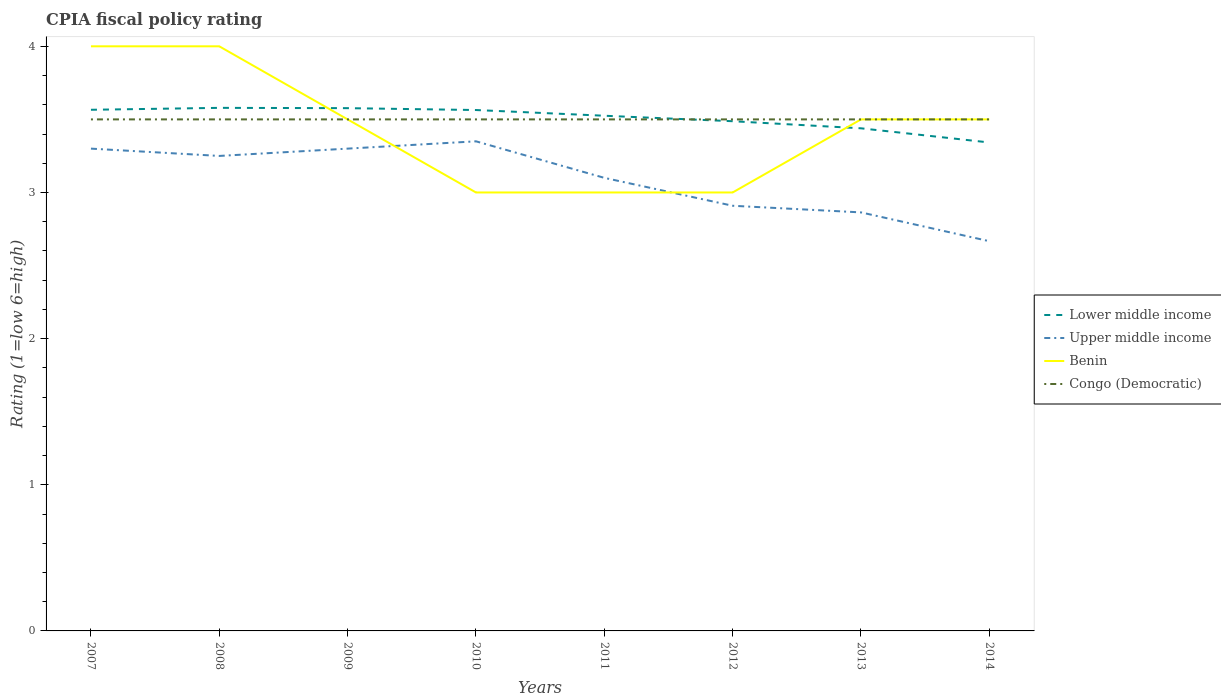How many different coloured lines are there?
Give a very brief answer. 4. Does the line corresponding to Lower middle income intersect with the line corresponding to Benin?
Offer a terse response. Yes. Across all years, what is the maximum CPIA rating in Benin?
Provide a short and direct response. 3. In which year was the CPIA rating in Lower middle income maximum?
Offer a very short reply. 2014. What is the total CPIA rating in Upper middle income in the graph?
Provide a succinct answer. 0. How many years are there in the graph?
Make the answer very short. 8. What is the difference between two consecutive major ticks on the Y-axis?
Make the answer very short. 1. Are the values on the major ticks of Y-axis written in scientific E-notation?
Keep it short and to the point. No. Does the graph contain any zero values?
Your answer should be very brief. No. Does the graph contain grids?
Offer a very short reply. No. Where does the legend appear in the graph?
Give a very brief answer. Center right. How many legend labels are there?
Give a very brief answer. 4. How are the legend labels stacked?
Your answer should be compact. Vertical. What is the title of the graph?
Make the answer very short. CPIA fiscal policy rating. Does "Zimbabwe" appear as one of the legend labels in the graph?
Provide a short and direct response. No. What is the label or title of the X-axis?
Make the answer very short. Years. What is the label or title of the Y-axis?
Keep it short and to the point. Rating (1=low 6=high). What is the Rating (1=low 6=high) in Lower middle income in 2007?
Your answer should be very brief. 3.57. What is the Rating (1=low 6=high) of Upper middle income in 2007?
Make the answer very short. 3.3. What is the Rating (1=low 6=high) in Benin in 2007?
Ensure brevity in your answer.  4. What is the Rating (1=low 6=high) of Congo (Democratic) in 2007?
Give a very brief answer. 3.5. What is the Rating (1=low 6=high) of Lower middle income in 2008?
Provide a succinct answer. 3.58. What is the Rating (1=low 6=high) of Upper middle income in 2008?
Your answer should be very brief. 3.25. What is the Rating (1=low 6=high) of Benin in 2008?
Keep it short and to the point. 4. What is the Rating (1=low 6=high) in Lower middle income in 2009?
Keep it short and to the point. 3.58. What is the Rating (1=low 6=high) in Upper middle income in 2009?
Make the answer very short. 3.3. What is the Rating (1=low 6=high) in Benin in 2009?
Offer a very short reply. 3.5. What is the Rating (1=low 6=high) in Lower middle income in 2010?
Your answer should be compact. 3.56. What is the Rating (1=low 6=high) in Upper middle income in 2010?
Offer a very short reply. 3.35. What is the Rating (1=low 6=high) of Lower middle income in 2011?
Ensure brevity in your answer.  3.52. What is the Rating (1=low 6=high) of Benin in 2011?
Make the answer very short. 3. What is the Rating (1=low 6=high) in Congo (Democratic) in 2011?
Keep it short and to the point. 3.5. What is the Rating (1=low 6=high) in Lower middle income in 2012?
Your response must be concise. 3.49. What is the Rating (1=low 6=high) in Upper middle income in 2012?
Offer a very short reply. 2.91. What is the Rating (1=low 6=high) in Benin in 2012?
Your response must be concise. 3. What is the Rating (1=low 6=high) of Congo (Democratic) in 2012?
Make the answer very short. 3.5. What is the Rating (1=low 6=high) in Lower middle income in 2013?
Ensure brevity in your answer.  3.44. What is the Rating (1=low 6=high) of Upper middle income in 2013?
Keep it short and to the point. 2.86. What is the Rating (1=low 6=high) of Benin in 2013?
Provide a short and direct response. 3.5. What is the Rating (1=low 6=high) in Congo (Democratic) in 2013?
Offer a terse response. 3.5. What is the Rating (1=low 6=high) of Lower middle income in 2014?
Offer a terse response. 3.34. What is the Rating (1=low 6=high) of Upper middle income in 2014?
Provide a succinct answer. 2.67. Across all years, what is the maximum Rating (1=low 6=high) in Lower middle income?
Provide a succinct answer. 3.58. Across all years, what is the maximum Rating (1=low 6=high) of Upper middle income?
Keep it short and to the point. 3.35. Across all years, what is the minimum Rating (1=low 6=high) of Lower middle income?
Provide a succinct answer. 3.34. Across all years, what is the minimum Rating (1=low 6=high) in Upper middle income?
Your response must be concise. 2.67. Across all years, what is the minimum Rating (1=low 6=high) in Congo (Democratic)?
Provide a short and direct response. 3.5. What is the total Rating (1=low 6=high) of Lower middle income in the graph?
Make the answer very short. 28.08. What is the total Rating (1=low 6=high) of Upper middle income in the graph?
Ensure brevity in your answer.  24.74. What is the total Rating (1=low 6=high) of Congo (Democratic) in the graph?
Provide a succinct answer. 28. What is the difference between the Rating (1=low 6=high) in Lower middle income in 2007 and that in 2008?
Ensure brevity in your answer.  -0.01. What is the difference between the Rating (1=low 6=high) of Lower middle income in 2007 and that in 2009?
Give a very brief answer. -0.01. What is the difference between the Rating (1=low 6=high) in Upper middle income in 2007 and that in 2009?
Offer a very short reply. 0. What is the difference between the Rating (1=low 6=high) in Benin in 2007 and that in 2009?
Your response must be concise. 0.5. What is the difference between the Rating (1=low 6=high) in Congo (Democratic) in 2007 and that in 2009?
Provide a short and direct response. 0. What is the difference between the Rating (1=low 6=high) in Lower middle income in 2007 and that in 2010?
Give a very brief answer. 0. What is the difference between the Rating (1=low 6=high) in Benin in 2007 and that in 2010?
Your response must be concise. 1. What is the difference between the Rating (1=low 6=high) in Congo (Democratic) in 2007 and that in 2010?
Your answer should be very brief. 0. What is the difference between the Rating (1=low 6=high) in Lower middle income in 2007 and that in 2011?
Your answer should be compact. 0.04. What is the difference between the Rating (1=low 6=high) of Upper middle income in 2007 and that in 2011?
Ensure brevity in your answer.  0.2. What is the difference between the Rating (1=low 6=high) in Benin in 2007 and that in 2011?
Your response must be concise. 1. What is the difference between the Rating (1=low 6=high) of Congo (Democratic) in 2007 and that in 2011?
Offer a terse response. 0. What is the difference between the Rating (1=low 6=high) of Lower middle income in 2007 and that in 2012?
Make the answer very short. 0.08. What is the difference between the Rating (1=low 6=high) in Upper middle income in 2007 and that in 2012?
Offer a terse response. 0.39. What is the difference between the Rating (1=low 6=high) in Lower middle income in 2007 and that in 2013?
Your answer should be very brief. 0.13. What is the difference between the Rating (1=low 6=high) in Upper middle income in 2007 and that in 2013?
Ensure brevity in your answer.  0.44. What is the difference between the Rating (1=low 6=high) of Benin in 2007 and that in 2013?
Make the answer very short. 0.5. What is the difference between the Rating (1=low 6=high) of Congo (Democratic) in 2007 and that in 2013?
Keep it short and to the point. 0. What is the difference between the Rating (1=low 6=high) in Lower middle income in 2007 and that in 2014?
Your response must be concise. 0.22. What is the difference between the Rating (1=low 6=high) in Upper middle income in 2007 and that in 2014?
Offer a terse response. 0.63. What is the difference between the Rating (1=low 6=high) of Lower middle income in 2008 and that in 2009?
Make the answer very short. 0. What is the difference between the Rating (1=low 6=high) in Congo (Democratic) in 2008 and that in 2009?
Ensure brevity in your answer.  0. What is the difference between the Rating (1=low 6=high) in Lower middle income in 2008 and that in 2010?
Your response must be concise. 0.01. What is the difference between the Rating (1=low 6=high) of Congo (Democratic) in 2008 and that in 2010?
Make the answer very short. 0. What is the difference between the Rating (1=low 6=high) in Lower middle income in 2008 and that in 2011?
Make the answer very short. 0.05. What is the difference between the Rating (1=low 6=high) of Lower middle income in 2008 and that in 2012?
Your answer should be compact. 0.09. What is the difference between the Rating (1=low 6=high) of Upper middle income in 2008 and that in 2012?
Your answer should be compact. 0.34. What is the difference between the Rating (1=low 6=high) of Benin in 2008 and that in 2012?
Make the answer very short. 1. What is the difference between the Rating (1=low 6=high) in Congo (Democratic) in 2008 and that in 2012?
Provide a short and direct response. 0. What is the difference between the Rating (1=low 6=high) of Lower middle income in 2008 and that in 2013?
Provide a short and direct response. 0.14. What is the difference between the Rating (1=low 6=high) in Upper middle income in 2008 and that in 2013?
Offer a terse response. 0.39. What is the difference between the Rating (1=low 6=high) of Benin in 2008 and that in 2013?
Provide a succinct answer. 0.5. What is the difference between the Rating (1=low 6=high) in Lower middle income in 2008 and that in 2014?
Make the answer very short. 0.24. What is the difference between the Rating (1=low 6=high) in Upper middle income in 2008 and that in 2014?
Your answer should be very brief. 0.58. What is the difference between the Rating (1=low 6=high) in Benin in 2008 and that in 2014?
Keep it short and to the point. 0.5. What is the difference between the Rating (1=low 6=high) of Lower middle income in 2009 and that in 2010?
Provide a short and direct response. 0.01. What is the difference between the Rating (1=low 6=high) of Upper middle income in 2009 and that in 2010?
Offer a very short reply. -0.05. What is the difference between the Rating (1=low 6=high) of Benin in 2009 and that in 2010?
Keep it short and to the point. 0.5. What is the difference between the Rating (1=low 6=high) in Lower middle income in 2009 and that in 2011?
Offer a very short reply. 0.05. What is the difference between the Rating (1=low 6=high) in Upper middle income in 2009 and that in 2011?
Your answer should be compact. 0.2. What is the difference between the Rating (1=low 6=high) in Congo (Democratic) in 2009 and that in 2011?
Keep it short and to the point. 0. What is the difference between the Rating (1=low 6=high) of Lower middle income in 2009 and that in 2012?
Your answer should be compact. 0.09. What is the difference between the Rating (1=low 6=high) in Upper middle income in 2009 and that in 2012?
Keep it short and to the point. 0.39. What is the difference between the Rating (1=low 6=high) in Benin in 2009 and that in 2012?
Your answer should be compact. 0.5. What is the difference between the Rating (1=low 6=high) in Lower middle income in 2009 and that in 2013?
Ensure brevity in your answer.  0.14. What is the difference between the Rating (1=low 6=high) in Upper middle income in 2009 and that in 2013?
Your response must be concise. 0.44. What is the difference between the Rating (1=low 6=high) of Benin in 2009 and that in 2013?
Offer a very short reply. 0. What is the difference between the Rating (1=low 6=high) of Congo (Democratic) in 2009 and that in 2013?
Offer a very short reply. 0. What is the difference between the Rating (1=low 6=high) in Lower middle income in 2009 and that in 2014?
Give a very brief answer. 0.23. What is the difference between the Rating (1=low 6=high) of Upper middle income in 2009 and that in 2014?
Keep it short and to the point. 0.63. What is the difference between the Rating (1=low 6=high) of Benin in 2009 and that in 2014?
Ensure brevity in your answer.  0. What is the difference between the Rating (1=low 6=high) of Lower middle income in 2010 and that in 2011?
Provide a short and direct response. 0.04. What is the difference between the Rating (1=low 6=high) in Upper middle income in 2010 and that in 2011?
Offer a very short reply. 0.25. What is the difference between the Rating (1=low 6=high) in Benin in 2010 and that in 2011?
Offer a terse response. 0. What is the difference between the Rating (1=low 6=high) of Congo (Democratic) in 2010 and that in 2011?
Your response must be concise. 0. What is the difference between the Rating (1=low 6=high) of Lower middle income in 2010 and that in 2012?
Your response must be concise. 0.08. What is the difference between the Rating (1=low 6=high) of Upper middle income in 2010 and that in 2012?
Your response must be concise. 0.44. What is the difference between the Rating (1=low 6=high) of Lower middle income in 2010 and that in 2013?
Provide a succinct answer. 0.13. What is the difference between the Rating (1=low 6=high) of Upper middle income in 2010 and that in 2013?
Offer a terse response. 0.49. What is the difference between the Rating (1=low 6=high) in Benin in 2010 and that in 2013?
Your response must be concise. -0.5. What is the difference between the Rating (1=low 6=high) of Lower middle income in 2010 and that in 2014?
Give a very brief answer. 0.22. What is the difference between the Rating (1=low 6=high) of Upper middle income in 2010 and that in 2014?
Your answer should be very brief. 0.68. What is the difference between the Rating (1=low 6=high) of Benin in 2010 and that in 2014?
Make the answer very short. -0.5. What is the difference between the Rating (1=low 6=high) of Congo (Democratic) in 2010 and that in 2014?
Offer a very short reply. 0. What is the difference between the Rating (1=low 6=high) in Lower middle income in 2011 and that in 2012?
Your response must be concise. 0.04. What is the difference between the Rating (1=low 6=high) of Upper middle income in 2011 and that in 2012?
Provide a succinct answer. 0.19. What is the difference between the Rating (1=low 6=high) of Congo (Democratic) in 2011 and that in 2012?
Give a very brief answer. 0. What is the difference between the Rating (1=low 6=high) of Lower middle income in 2011 and that in 2013?
Offer a terse response. 0.09. What is the difference between the Rating (1=low 6=high) in Upper middle income in 2011 and that in 2013?
Give a very brief answer. 0.24. What is the difference between the Rating (1=low 6=high) in Lower middle income in 2011 and that in 2014?
Offer a very short reply. 0.18. What is the difference between the Rating (1=low 6=high) in Upper middle income in 2011 and that in 2014?
Your answer should be very brief. 0.43. What is the difference between the Rating (1=low 6=high) of Congo (Democratic) in 2011 and that in 2014?
Ensure brevity in your answer.  0. What is the difference between the Rating (1=low 6=high) in Lower middle income in 2012 and that in 2013?
Keep it short and to the point. 0.05. What is the difference between the Rating (1=low 6=high) of Upper middle income in 2012 and that in 2013?
Your answer should be very brief. 0.05. What is the difference between the Rating (1=low 6=high) in Lower middle income in 2012 and that in 2014?
Your response must be concise. 0.15. What is the difference between the Rating (1=low 6=high) in Upper middle income in 2012 and that in 2014?
Provide a short and direct response. 0.24. What is the difference between the Rating (1=low 6=high) of Lower middle income in 2013 and that in 2014?
Your answer should be compact. 0.1. What is the difference between the Rating (1=low 6=high) in Upper middle income in 2013 and that in 2014?
Make the answer very short. 0.2. What is the difference between the Rating (1=low 6=high) in Benin in 2013 and that in 2014?
Make the answer very short. 0. What is the difference between the Rating (1=low 6=high) in Lower middle income in 2007 and the Rating (1=low 6=high) in Upper middle income in 2008?
Your response must be concise. 0.32. What is the difference between the Rating (1=low 6=high) in Lower middle income in 2007 and the Rating (1=low 6=high) in Benin in 2008?
Your answer should be compact. -0.43. What is the difference between the Rating (1=low 6=high) in Lower middle income in 2007 and the Rating (1=low 6=high) in Congo (Democratic) in 2008?
Offer a terse response. 0.07. What is the difference between the Rating (1=low 6=high) in Lower middle income in 2007 and the Rating (1=low 6=high) in Upper middle income in 2009?
Your answer should be compact. 0.27. What is the difference between the Rating (1=low 6=high) in Lower middle income in 2007 and the Rating (1=low 6=high) in Benin in 2009?
Your response must be concise. 0.07. What is the difference between the Rating (1=low 6=high) in Lower middle income in 2007 and the Rating (1=low 6=high) in Congo (Democratic) in 2009?
Offer a very short reply. 0.07. What is the difference between the Rating (1=low 6=high) in Upper middle income in 2007 and the Rating (1=low 6=high) in Congo (Democratic) in 2009?
Your answer should be compact. -0.2. What is the difference between the Rating (1=low 6=high) in Lower middle income in 2007 and the Rating (1=low 6=high) in Upper middle income in 2010?
Give a very brief answer. 0.22. What is the difference between the Rating (1=low 6=high) of Lower middle income in 2007 and the Rating (1=low 6=high) of Benin in 2010?
Your answer should be compact. 0.57. What is the difference between the Rating (1=low 6=high) of Lower middle income in 2007 and the Rating (1=low 6=high) of Congo (Democratic) in 2010?
Offer a terse response. 0.07. What is the difference between the Rating (1=low 6=high) of Upper middle income in 2007 and the Rating (1=low 6=high) of Benin in 2010?
Provide a short and direct response. 0.3. What is the difference between the Rating (1=low 6=high) in Benin in 2007 and the Rating (1=low 6=high) in Congo (Democratic) in 2010?
Keep it short and to the point. 0.5. What is the difference between the Rating (1=low 6=high) of Lower middle income in 2007 and the Rating (1=low 6=high) of Upper middle income in 2011?
Provide a succinct answer. 0.47. What is the difference between the Rating (1=low 6=high) in Lower middle income in 2007 and the Rating (1=low 6=high) in Benin in 2011?
Provide a succinct answer. 0.57. What is the difference between the Rating (1=low 6=high) of Lower middle income in 2007 and the Rating (1=low 6=high) of Congo (Democratic) in 2011?
Your response must be concise. 0.07. What is the difference between the Rating (1=low 6=high) in Upper middle income in 2007 and the Rating (1=low 6=high) in Congo (Democratic) in 2011?
Provide a succinct answer. -0.2. What is the difference between the Rating (1=low 6=high) in Lower middle income in 2007 and the Rating (1=low 6=high) in Upper middle income in 2012?
Offer a very short reply. 0.66. What is the difference between the Rating (1=low 6=high) of Lower middle income in 2007 and the Rating (1=low 6=high) of Benin in 2012?
Your response must be concise. 0.57. What is the difference between the Rating (1=low 6=high) of Lower middle income in 2007 and the Rating (1=low 6=high) of Congo (Democratic) in 2012?
Offer a very short reply. 0.07. What is the difference between the Rating (1=low 6=high) in Upper middle income in 2007 and the Rating (1=low 6=high) in Benin in 2012?
Make the answer very short. 0.3. What is the difference between the Rating (1=low 6=high) in Upper middle income in 2007 and the Rating (1=low 6=high) in Congo (Democratic) in 2012?
Your response must be concise. -0.2. What is the difference between the Rating (1=low 6=high) of Lower middle income in 2007 and the Rating (1=low 6=high) of Upper middle income in 2013?
Ensure brevity in your answer.  0.7. What is the difference between the Rating (1=low 6=high) of Lower middle income in 2007 and the Rating (1=low 6=high) of Benin in 2013?
Give a very brief answer. 0.07. What is the difference between the Rating (1=low 6=high) of Lower middle income in 2007 and the Rating (1=low 6=high) of Congo (Democratic) in 2013?
Keep it short and to the point. 0.07. What is the difference between the Rating (1=low 6=high) of Upper middle income in 2007 and the Rating (1=low 6=high) of Congo (Democratic) in 2013?
Offer a very short reply. -0.2. What is the difference between the Rating (1=low 6=high) of Benin in 2007 and the Rating (1=low 6=high) of Congo (Democratic) in 2013?
Give a very brief answer. 0.5. What is the difference between the Rating (1=low 6=high) of Lower middle income in 2007 and the Rating (1=low 6=high) of Upper middle income in 2014?
Provide a succinct answer. 0.9. What is the difference between the Rating (1=low 6=high) in Lower middle income in 2007 and the Rating (1=low 6=high) in Benin in 2014?
Your answer should be compact. 0.07. What is the difference between the Rating (1=low 6=high) of Lower middle income in 2007 and the Rating (1=low 6=high) of Congo (Democratic) in 2014?
Provide a short and direct response. 0.07. What is the difference between the Rating (1=low 6=high) of Benin in 2007 and the Rating (1=low 6=high) of Congo (Democratic) in 2014?
Ensure brevity in your answer.  0.5. What is the difference between the Rating (1=low 6=high) of Lower middle income in 2008 and the Rating (1=low 6=high) of Upper middle income in 2009?
Provide a succinct answer. 0.28. What is the difference between the Rating (1=low 6=high) in Lower middle income in 2008 and the Rating (1=low 6=high) in Benin in 2009?
Provide a short and direct response. 0.08. What is the difference between the Rating (1=low 6=high) in Lower middle income in 2008 and the Rating (1=low 6=high) in Congo (Democratic) in 2009?
Offer a terse response. 0.08. What is the difference between the Rating (1=low 6=high) of Upper middle income in 2008 and the Rating (1=low 6=high) of Benin in 2009?
Your response must be concise. -0.25. What is the difference between the Rating (1=low 6=high) of Upper middle income in 2008 and the Rating (1=low 6=high) of Congo (Democratic) in 2009?
Your answer should be compact. -0.25. What is the difference between the Rating (1=low 6=high) in Benin in 2008 and the Rating (1=low 6=high) in Congo (Democratic) in 2009?
Ensure brevity in your answer.  0.5. What is the difference between the Rating (1=low 6=high) in Lower middle income in 2008 and the Rating (1=low 6=high) in Upper middle income in 2010?
Offer a terse response. 0.23. What is the difference between the Rating (1=low 6=high) of Lower middle income in 2008 and the Rating (1=low 6=high) of Benin in 2010?
Your answer should be very brief. 0.58. What is the difference between the Rating (1=low 6=high) in Lower middle income in 2008 and the Rating (1=low 6=high) in Congo (Democratic) in 2010?
Offer a terse response. 0.08. What is the difference between the Rating (1=low 6=high) in Upper middle income in 2008 and the Rating (1=low 6=high) in Benin in 2010?
Ensure brevity in your answer.  0.25. What is the difference between the Rating (1=low 6=high) of Upper middle income in 2008 and the Rating (1=low 6=high) of Congo (Democratic) in 2010?
Offer a terse response. -0.25. What is the difference between the Rating (1=low 6=high) of Benin in 2008 and the Rating (1=low 6=high) of Congo (Democratic) in 2010?
Your response must be concise. 0.5. What is the difference between the Rating (1=low 6=high) in Lower middle income in 2008 and the Rating (1=low 6=high) in Upper middle income in 2011?
Keep it short and to the point. 0.48. What is the difference between the Rating (1=low 6=high) in Lower middle income in 2008 and the Rating (1=low 6=high) in Benin in 2011?
Your answer should be very brief. 0.58. What is the difference between the Rating (1=low 6=high) of Lower middle income in 2008 and the Rating (1=low 6=high) of Congo (Democratic) in 2011?
Make the answer very short. 0.08. What is the difference between the Rating (1=low 6=high) in Upper middle income in 2008 and the Rating (1=low 6=high) in Congo (Democratic) in 2011?
Ensure brevity in your answer.  -0.25. What is the difference between the Rating (1=low 6=high) of Lower middle income in 2008 and the Rating (1=low 6=high) of Upper middle income in 2012?
Provide a short and direct response. 0.67. What is the difference between the Rating (1=low 6=high) of Lower middle income in 2008 and the Rating (1=low 6=high) of Benin in 2012?
Keep it short and to the point. 0.58. What is the difference between the Rating (1=low 6=high) of Lower middle income in 2008 and the Rating (1=low 6=high) of Congo (Democratic) in 2012?
Provide a succinct answer. 0.08. What is the difference between the Rating (1=low 6=high) of Upper middle income in 2008 and the Rating (1=low 6=high) of Benin in 2012?
Offer a terse response. 0.25. What is the difference between the Rating (1=low 6=high) in Upper middle income in 2008 and the Rating (1=low 6=high) in Congo (Democratic) in 2012?
Your answer should be very brief. -0.25. What is the difference between the Rating (1=low 6=high) of Benin in 2008 and the Rating (1=low 6=high) of Congo (Democratic) in 2012?
Ensure brevity in your answer.  0.5. What is the difference between the Rating (1=low 6=high) in Lower middle income in 2008 and the Rating (1=low 6=high) in Upper middle income in 2013?
Keep it short and to the point. 0.72. What is the difference between the Rating (1=low 6=high) in Lower middle income in 2008 and the Rating (1=low 6=high) in Benin in 2013?
Offer a terse response. 0.08. What is the difference between the Rating (1=low 6=high) in Lower middle income in 2008 and the Rating (1=low 6=high) in Congo (Democratic) in 2013?
Your answer should be very brief. 0.08. What is the difference between the Rating (1=low 6=high) in Lower middle income in 2008 and the Rating (1=low 6=high) in Upper middle income in 2014?
Provide a succinct answer. 0.91. What is the difference between the Rating (1=low 6=high) of Lower middle income in 2008 and the Rating (1=low 6=high) of Benin in 2014?
Your answer should be very brief. 0.08. What is the difference between the Rating (1=low 6=high) in Lower middle income in 2008 and the Rating (1=low 6=high) in Congo (Democratic) in 2014?
Ensure brevity in your answer.  0.08. What is the difference between the Rating (1=low 6=high) of Upper middle income in 2008 and the Rating (1=low 6=high) of Congo (Democratic) in 2014?
Ensure brevity in your answer.  -0.25. What is the difference between the Rating (1=low 6=high) of Benin in 2008 and the Rating (1=low 6=high) of Congo (Democratic) in 2014?
Your answer should be compact. 0.5. What is the difference between the Rating (1=low 6=high) in Lower middle income in 2009 and the Rating (1=low 6=high) in Upper middle income in 2010?
Provide a succinct answer. 0.23. What is the difference between the Rating (1=low 6=high) in Lower middle income in 2009 and the Rating (1=low 6=high) in Benin in 2010?
Your answer should be very brief. 0.58. What is the difference between the Rating (1=low 6=high) in Lower middle income in 2009 and the Rating (1=low 6=high) in Congo (Democratic) in 2010?
Give a very brief answer. 0.08. What is the difference between the Rating (1=low 6=high) in Upper middle income in 2009 and the Rating (1=low 6=high) in Benin in 2010?
Your answer should be very brief. 0.3. What is the difference between the Rating (1=low 6=high) of Lower middle income in 2009 and the Rating (1=low 6=high) of Upper middle income in 2011?
Offer a very short reply. 0.48. What is the difference between the Rating (1=low 6=high) of Lower middle income in 2009 and the Rating (1=low 6=high) of Benin in 2011?
Offer a very short reply. 0.58. What is the difference between the Rating (1=low 6=high) of Lower middle income in 2009 and the Rating (1=low 6=high) of Congo (Democratic) in 2011?
Your answer should be compact. 0.08. What is the difference between the Rating (1=low 6=high) in Upper middle income in 2009 and the Rating (1=low 6=high) in Benin in 2011?
Your response must be concise. 0.3. What is the difference between the Rating (1=low 6=high) in Upper middle income in 2009 and the Rating (1=low 6=high) in Congo (Democratic) in 2011?
Make the answer very short. -0.2. What is the difference between the Rating (1=low 6=high) in Lower middle income in 2009 and the Rating (1=low 6=high) in Upper middle income in 2012?
Provide a short and direct response. 0.67. What is the difference between the Rating (1=low 6=high) in Lower middle income in 2009 and the Rating (1=low 6=high) in Benin in 2012?
Offer a very short reply. 0.58. What is the difference between the Rating (1=low 6=high) in Lower middle income in 2009 and the Rating (1=low 6=high) in Congo (Democratic) in 2012?
Provide a succinct answer. 0.08. What is the difference between the Rating (1=low 6=high) of Upper middle income in 2009 and the Rating (1=low 6=high) of Congo (Democratic) in 2012?
Provide a succinct answer. -0.2. What is the difference between the Rating (1=low 6=high) of Lower middle income in 2009 and the Rating (1=low 6=high) of Upper middle income in 2013?
Provide a short and direct response. 0.71. What is the difference between the Rating (1=low 6=high) of Lower middle income in 2009 and the Rating (1=low 6=high) of Benin in 2013?
Provide a short and direct response. 0.08. What is the difference between the Rating (1=low 6=high) in Lower middle income in 2009 and the Rating (1=low 6=high) in Congo (Democratic) in 2013?
Your answer should be very brief. 0.08. What is the difference between the Rating (1=low 6=high) in Upper middle income in 2009 and the Rating (1=low 6=high) in Benin in 2013?
Ensure brevity in your answer.  -0.2. What is the difference between the Rating (1=low 6=high) in Lower middle income in 2009 and the Rating (1=low 6=high) in Upper middle income in 2014?
Provide a short and direct response. 0.91. What is the difference between the Rating (1=low 6=high) of Lower middle income in 2009 and the Rating (1=low 6=high) of Benin in 2014?
Offer a very short reply. 0.08. What is the difference between the Rating (1=low 6=high) of Lower middle income in 2009 and the Rating (1=low 6=high) of Congo (Democratic) in 2014?
Provide a short and direct response. 0.08. What is the difference between the Rating (1=low 6=high) in Upper middle income in 2009 and the Rating (1=low 6=high) in Benin in 2014?
Offer a very short reply. -0.2. What is the difference between the Rating (1=low 6=high) in Benin in 2009 and the Rating (1=low 6=high) in Congo (Democratic) in 2014?
Provide a short and direct response. 0. What is the difference between the Rating (1=low 6=high) of Lower middle income in 2010 and the Rating (1=low 6=high) of Upper middle income in 2011?
Give a very brief answer. 0.46. What is the difference between the Rating (1=low 6=high) of Lower middle income in 2010 and the Rating (1=low 6=high) of Benin in 2011?
Your answer should be compact. 0.56. What is the difference between the Rating (1=low 6=high) of Lower middle income in 2010 and the Rating (1=low 6=high) of Congo (Democratic) in 2011?
Your answer should be compact. 0.06. What is the difference between the Rating (1=low 6=high) of Lower middle income in 2010 and the Rating (1=low 6=high) of Upper middle income in 2012?
Make the answer very short. 0.66. What is the difference between the Rating (1=low 6=high) of Lower middle income in 2010 and the Rating (1=low 6=high) of Benin in 2012?
Your answer should be compact. 0.56. What is the difference between the Rating (1=low 6=high) of Lower middle income in 2010 and the Rating (1=low 6=high) of Congo (Democratic) in 2012?
Provide a succinct answer. 0.06. What is the difference between the Rating (1=low 6=high) in Benin in 2010 and the Rating (1=low 6=high) in Congo (Democratic) in 2012?
Ensure brevity in your answer.  -0.5. What is the difference between the Rating (1=low 6=high) of Lower middle income in 2010 and the Rating (1=low 6=high) of Upper middle income in 2013?
Your answer should be compact. 0.7. What is the difference between the Rating (1=low 6=high) in Lower middle income in 2010 and the Rating (1=low 6=high) in Benin in 2013?
Make the answer very short. 0.06. What is the difference between the Rating (1=low 6=high) in Lower middle income in 2010 and the Rating (1=low 6=high) in Congo (Democratic) in 2013?
Give a very brief answer. 0.06. What is the difference between the Rating (1=low 6=high) of Upper middle income in 2010 and the Rating (1=low 6=high) of Congo (Democratic) in 2013?
Your answer should be very brief. -0.15. What is the difference between the Rating (1=low 6=high) of Benin in 2010 and the Rating (1=low 6=high) of Congo (Democratic) in 2013?
Your response must be concise. -0.5. What is the difference between the Rating (1=low 6=high) of Lower middle income in 2010 and the Rating (1=low 6=high) of Upper middle income in 2014?
Make the answer very short. 0.9. What is the difference between the Rating (1=low 6=high) of Lower middle income in 2010 and the Rating (1=low 6=high) of Benin in 2014?
Provide a succinct answer. 0.06. What is the difference between the Rating (1=low 6=high) of Lower middle income in 2010 and the Rating (1=low 6=high) of Congo (Democratic) in 2014?
Provide a succinct answer. 0.06. What is the difference between the Rating (1=low 6=high) in Upper middle income in 2010 and the Rating (1=low 6=high) in Benin in 2014?
Ensure brevity in your answer.  -0.15. What is the difference between the Rating (1=low 6=high) in Benin in 2010 and the Rating (1=low 6=high) in Congo (Democratic) in 2014?
Provide a succinct answer. -0.5. What is the difference between the Rating (1=low 6=high) of Lower middle income in 2011 and the Rating (1=low 6=high) of Upper middle income in 2012?
Your answer should be very brief. 0.62. What is the difference between the Rating (1=low 6=high) in Lower middle income in 2011 and the Rating (1=low 6=high) in Benin in 2012?
Give a very brief answer. 0.53. What is the difference between the Rating (1=low 6=high) in Lower middle income in 2011 and the Rating (1=low 6=high) in Congo (Democratic) in 2012?
Provide a succinct answer. 0.03. What is the difference between the Rating (1=low 6=high) in Upper middle income in 2011 and the Rating (1=low 6=high) in Benin in 2012?
Offer a terse response. 0.1. What is the difference between the Rating (1=low 6=high) in Upper middle income in 2011 and the Rating (1=low 6=high) in Congo (Democratic) in 2012?
Your response must be concise. -0.4. What is the difference between the Rating (1=low 6=high) of Lower middle income in 2011 and the Rating (1=low 6=high) of Upper middle income in 2013?
Your answer should be compact. 0.66. What is the difference between the Rating (1=low 6=high) in Lower middle income in 2011 and the Rating (1=low 6=high) in Benin in 2013?
Your answer should be very brief. 0.03. What is the difference between the Rating (1=low 6=high) of Lower middle income in 2011 and the Rating (1=low 6=high) of Congo (Democratic) in 2013?
Make the answer very short. 0.03. What is the difference between the Rating (1=low 6=high) of Upper middle income in 2011 and the Rating (1=low 6=high) of Benin in 2013?
Your response must be concise. -0.4. What is the difference between the Rating (1=low 6=high) of Upper middle income in 2011 and the Rating (1=low 6=high) of Congo (Democratic) in 2013?
Ensure brevity in your answer.  -0.4. What is the difference between the Rating (1=low 6=high) of Benin in 2011 and the Rating (1=low 6=high) of Congo (Democratic) in 2013?
Your response must be concise. -0.5. What is the difference between the Rating (1=low 6=high) of Lower middle income in 2011 and the Rating (1=low 6=high) of Upper middle income in 2014?
Offer a terse response. 0.86. What is the difference between the Rating (1=low 6=high) of Lower middle income in 2011 and the Rating (1=low 6=high) of Benin in 2014?
Your answer should be very brief. 0.03. What is the difference between the Rating (1=low 6=high) of Lower middle income in 2011 and the Rating (1=low 6=high) of Congo (Democratic) in 2014?
Keep it short and to the point. 0.03. What is the difference between the Rating (1=low 6=high) in Upper middle income in 2011 and the Rating (1=low 6=high) in Congo (Democratic) in 2014?
Offer a very short reply. -0.4. What is the difference between the Rating (1=low 6=high) in Lower middle income in 2012 and the Rating (1=low 6=high) in Upper middle income in 2013?
Offer a very short reply. 0.62. What is the difference between the Rating (1=low 6=high) of Lower middle income in 2012 and the Rating (1=low 6=high) of Benin in 2013?
Offer a very short reply. -0.01. What is the difference between the Rating (1=low 6=high) of Lower middle income in 2012 and the Rating (1=low 6=high) of Congo (Democratic) in 2013?
Ensure brevity in your answer.  -0.01. What is the difference between the Rating (1=low 6=high) in Upper middle income in 2012 and the Rating (1=low 6=high) in Benin in 2013?
Provide a succinct answer. -0.59. What is the difference between the Rating (1=low 6=high) of Upper middle income in 2012 and the Rating (1=low 6=high) of Congo (Democratic) in 2013?
Your response must be concise. -0.59. What is the difference between the Rating (1=low 6=high) of Benin in 2012 and the Rating (1=low 6=high) of Congo (Democratic) in 2013?
Offer a very short reply. -0.5. What is the difference between the Rating (1=low 6=high) of Lower middle income in 2012 and the Rating (1=low 6=high) of Upper middle income in 2014?
Your response must be concise. 0.82. What is the difference between the Rating (1=low 6=high) in Lower middle income in 2012 and the Rating (1=low 6=high) in Benin in 2014?
Offer a terse response. -0.01. What is the difference between the Rating (1=low 6=high) in Lower middle income in 2012 and the Rating (1=low 6=high) in Congo (Democratic) in 2014?
Your response must be concise. -0.01. What is the difference between the Rating (1=low 6=high) in Upper middle income in 2012 and the Rating (1=low 6=high) in Benin in 2014?
Keep it short and to the point. -0.59. What is the difference between the Rating (1=low 6=high) of Upper middle income in 2012 and the Rating (1=low 6=high) of Congo (Democratic) in 2014?
Give a very brief answer. -0.59. What is the difference between the Rating (1=low 6=high) in Lower middle income in 2013 and the Rating (1=low 6=high) in Upper middle income in 2014?
Your answer should be very brief. 0.77. What is the difference between the Rating (1=low 6=high) of Lower middle income in 2013 and the Rating (1=low 6=high) of Benin in 2014?
Give a very brief answer. -0.06. What is the difference between the Rating (1=low 6=high) in Lower middle income in 2013 and the Rating (1=low 6=high) in Congo (Democratic) in 2014?
Offer a very short reply. -0.06. What is the difference between the Rating (1=low 6=high) in Upper middle income in 2013 and the Rating (1=low 6=high) in Benin in 2014?
Your answer should be very brief. -0.64. What is the difference between the Rating (1=low 6=high) of Upper middle income in 2013 and the Rating (1=low 6=high) of Congo (Democratic) in 2014?
Provide a succinct answer. -0.64. What is the difference between the Rating (1=low 6=high) in Benin in 2013 and the Rating (1=low 6=high) in Congo (Democratic) in 2014?
Provide a short and direct response. 0. What is the average Rating (1=low 6=high) in Lower middle income per year?
Provide a succinct answer. 3.51. What is the average Rating (1=low 6=high) of Upper middle income per year?
Provide a succinct answer. 3.09. What is the average Rating (1=low 6=high) of Benin per year?
Ensure brevity in your answer.  3.44. What is the average Rating (1=low 6=high) of Congo (Democratic) per year?
Provide a succinct answer. 3.5. In the year 2007, what is the difference between the Rating (1=low 6=high) of Lower middle income and Rating (1=low 6=high) of Upper middle income?
Your response must be concise. 0.27. In the year 2007, what is the difference between the Rating (1=low 6=high) in Lower middle income and Rating (1=low 6=high) in Benin?
Make the answer very short. -0.43. In the year 2007, what is the difference between the Rating (1=low 6=high) in Lower middle income and Rating (1=low 6=high) in Congo (Democratic)?
Offer a terse response. 0.07. In the year 2007, what is the difference between the Rating (1=low 6=high) of Upper middle income and Rating (1=low 6=high) of Benin?
Provide a short and direct response. -0.7. In the year 2007, what is the difference between the Rating (1=low 6=high) in Benin and Rating (1=low 6=high) in Congo (Democratic)?
Make the answer very short. 0.5. In the year 2008, what is the difference between the Rating (1=low 6=high) in Lower middle income and Rating (1=low 6=high) in Upper middle income?
Ensure brevity in your answer.  0.33. In the year 2008, what is the difference between the Rating (1=low 6=high) of Lower middle income and Rating (1=low 6=high) of Benin?
Keep it short and to the point. -0.42. In the year 2008, what is the difference between the Rating (1=low 6=high) of Lower middle income and Rating (1=low 6=high) of Congo (Democratic)?
Provide a short and direct response. 0.08. In the year 2008, what is the difference between the Rating (1=low 6=high) in Upper middle income and Rating (1=low 6=high) in Benin?
Ensure brevity in your answer.  -0.75. In the year 2008, what is the difference between the Rating (1=low 6=high) of Benin and Rating (1=low 6=high) of Congo (Democratic)?
Give a very brief answer. 0.5. In the year 2009, what is the difference between the Rating (1=low 6=high) of Lower middle income and Rating (1=low 6=high) of Upper middle income?
Give a very brief answer. 0.28. In the year 2009, what is the difference between the Rating (1=low 6=high) in Lower middle income and Rating (1=low 6=high) in Benin?
Your answer should be very brief. 0.08. In the year 2009, what is the difference between the Rating (1=low 6=high) of Lower middle income and Rating (1=low 6=high) of Congo (Democratic)?
Provide a succinct answer. 0.08. In the year 2009, what is the difference between the Rating (1=low 6=high) of Upper middle income and Rating (1=low 6=high) of Benin?
Provide a short and direct response. -0.2. In the year 2009, what is the difference between the Rating (1=low 6=high) of Upper middle income and Rating (1=low 6=high) of Congo (Democratic)?
Offer a very short reply. -0.2. In the year 2009, what is the difference between the Rating (1=low 6=high) of Benin and Rating (1=low 6=high) of Congo (Democratic)?
Your answer should be very brief. 0. In the year 2010, what is the difference between the Rating (1=low 6=high) in Lower middle income and Rating (1=low 6=high) in Upper middle income?
Provide a succinct answer. 0.21. In the year 2010, what is the difference between the Rating (1=low 6=high) in Lower middle income and Rating (1=low 6=high) in Benin?
Offer a terse response. 0.56. In the year 2010, what is the difference between the Rating (1=low 6=high) in Lower middle income and Rating (1=low 6=high) in Congo (Democratic)?
Your answer should be compact. 0.06. In the year 2011, what is the difference between the Rating (1=low 6=high) of Lower middle income and Rating (1=low 6=high) of Upper middle income?
Keep it short and to the point. 0.42. In the year 2011, what is the difference between the Rating (1=low 6=high) in Lower middle income and Rating (1=low 6=high) in Benin?
Make the answer very short. 0.53. In the year 2011, what is the difference between the Rating (1=low 6=high) in Lower middle income and Rating (1=low 6=high) in Congo (Democratic)?
Provide a succinct answer. 0.03. In the year 2011, what is the difference between the Rating (1=low 6=high) of Upper middle income and Rating (1=low 6=high) of Benin?
Give a very brief answer. 0.1. In the year 2011, what is the difference between the Rating (1=low 6=high) in Upper middle income and Rating (1=low 6=high) in Congo (Democratic)?
Your answer should be compact. -0.4. In the year 2011, what is the difference between the Rating (1=low 6=high) of Benin and Rating (1=low 6=high) of Congo (Democratic)?
Your answer should be compact. -0.5. In the year 2012, what is the difference between the Rating (1=low 6=high) of Lower middle income and Rating (1=low 6=high) of Upper middle income?
Offer a terse response. 0.58. In the year 2012, what is the difference between the Rating (1=low 6=high) in Lower middle income and Rating (1=low 6=high) in Benin?
Your response must be concise. 0.49. In the year 2012, what is the difference between the Rating (1=low 6=high) of Lower middle income and Rating (1=low 6=high) of Congo (Democratic)?
Give a very brief answer. -0.01. In the year 2012, what is the difference between the Rating (1=low 6=high) of Upper middle income and Rating (1=low 6=high) of Benin?
Your answer should be compact. -0.09. In the year 2012, what is the difference between the Rating (1=low 6=high) in Upper middle income and Rating (1=low 6=high) in Congo (Democratic)?
Give a very brief answer. -0.59. In the year 2013, what is the difference between the Rating (1=low 6=high) in Lower middle income and Rating (1=low 6=high) in Upper middle income?
Offer a terse response. 0.58. In the year 2013, what is the difference between the Rating (1=low 6=high) in Lower middle income and Rating (1=low 6=high) in Benin?
Your response must be concise. -0.06. In the year 2013, what is the difference between the Rating (1=low 6=high) of Lower middle income and Rating (1=low 6=high) of Congo (Democratic)?
Provide a succinct answer. -0.06. In the year 2013, what is the difference between the Rating (1=low 6=high) in Upper middle income and Rating (1=low 6=high) in Benin?
Your answer should be compact. -0.64. In the year 2013, what is the difference between the Rating (1=low 6=high) of Upper middle income and Rating (1=low 6=high) of Congo (Democratic)?
Provide a succinct answer. -0.64. In the year 2014, what is the difference between the Rating (1=low 6=high) in Lower middle income and Rating (1=low 6=high) in Upper middle income?
Provide a short and direct response. 0.68. In the year 2014, what is the difference between the Rating (1=low 6=high) of Lower middle income and Rating (1=low 6=high) of Benin?
Provide a succinct answer. -0.16. In the year 2014, what is the difference between the Rating (1=low 6=high) of Lower middle income and Rating (1=low 6=high) of Congo (Democratic)?
Make the answer very short. -0.16. In the year 2014, what is the difference between the Rating (1=low 6=high) of Upper middle income and Rating (1=low 6=high) of Benin?
Make the answer very short. -0.83. In the year 2014, what is the difference between the Rating (1=low 6=high) of Benin and Rating (1=low 6=high) of Congo (Democratic)?
Your response must be concise. 0. What is the ratio of the Rating (1=low 6=high) in Upper middle income in 2007 to that in 2008?
Keep it short and to the point. 1.02. What is the ratio of the Rating (1=low 6=high) of Benin in 2007 to that in 2008?
Keep it short and to the point. 1. What is the ratio of the Rating (1=low 6=high) in Congo (Democratic) in 2007 to that in 2008?
Give a very brief answer. 1. What is the ratio of the Rating (1=low 6=high) of Upper middle income in 2007 to that in 2009?
Your response must be concise. 1. What is the ratio of the Rating (1=low 6=high) in Benin in 2007 to that in 2009?
Provide a succinct answer. 1.14. What is the ratio of the Rating (1=low 6=high) of Lower middle income in 2007 to that in 2010?
Your answer should be compact. 1. What is the ratio of the Rating (1=low 6=high) of Upper middle income in 2007 to that in 2010?
Give a very brief answer. 0.99. What is the ratio of the Rating (1=low 6=high) of Benin in 2007 to that in 2010?
Your answer should be compact. 1.33. What is the ratio of the Rating (1=low 6=high) in Congo (Democratic) in 2007 to that in 2010?
Offer a terse response. 1. What is the ratio of the Rating (1=low 6=high) of Lower middle income in 2007 to that in 2011?
Your answer should be very brief. 1.01. What is the ratio of the Rating (1=low 6=high) in Upper middle income in 2007 to that in 2011?
Provide a succinct answer. 1.06. What is the ratio of the Rating (1=low 6=high) in Lower middle income in 2007 to that in 2012?
Offer a very short reply. 1.02. What is the ratio of the Rating (1=low 6=high) of Upper middle income in 2007 to that in 2012?
Your response must be concise. 1.13. What is the ratio of the Rating (1=low 6=high) of Lower middle income in 2007 to that in 2013?
Provide a succinct answer. 1.04. What is the ratio of the Rating (1=low 6=high) in Upper middle income in 2007 to that in 2013?
Your response must be concise. 1.15. What is the ratio of the Rating (1=low 6=high) of Congo (Democratic) in 2007 to that in 2013?
Offer a very short reply. 1. What is the ratio of the Rating (1=low 6=high) in Lower middle income in 2007 to that in 2014?
Offer a very short reply. 1.07. What is the ratio of the Rating (1=low 6=high) of Upper middle income in 2007 to that in 2014?
Keep it short and to the point. 1.24. What is the ratio of the Rating (1=low 6=high) in Lower middle income in 2008 to that in 2009?
Keep it short and to the point. 1. What is the ratio of the Rating (1=low 6=high) in Upper middle income in 2008 to that in 2009?
Ensure brevity in your answer.  0.98. What is the ratio of the Rating (1=low 6=high) of Benin in 2008 to that in 2009?
Keep it short and to the point. 1.14. What is the ratio of the Rating (1=low 6=high) in Congo (Democratic) in 2008 to that in 2009?
Make the answer very short. 1. What is the ratio of the Rating (1=low 6=high) in Lower middle income in 2008 to that in 2010?
Ensure brevity in your answer.  1. What is the ratio of the Rating (1=low 6=high) of Upper middle income in 2008 to that in 2010?
Keep it short and to the point. 0.97. What is the ratio of the Rating (1=low 6=high) in Lower middle income in 2008 to that in 2011?
Offer a terse response. 1.02. What is the ratio of the Rating (1=low 6=high) in Upper middle income in 2008 to that in 2011?
Provide a short and direct response. 1.05. What is the ratio of the Rating (1=low 6=high) in Congo (Democratic) in 2008 to that in 2011?
Your answer should be very brief. 1. What is the ratio of the Rating (1=low 6=high) in Lower middle income in 2008 to that in 2012?
Your answer should be very brief. 1.03. What is the ratio of the Rating (1=low 6=high) of Upper middle income in 2008 to that in 2012?
Make the answer very short. 1.12. What is the ratio of the Rating (1=low 6=high) of Benin in 2008 to that in 2012?
Give a very brief answer. 1.33. What is the ratio of the Rating (1=low 6=high) of Congo (Democratic) in 2008 to that in 2012?
Keep it short and to the point. 1. What is the ratio of the Rating (1=low 6=high) of Lower middle income in 2008 to that in 2013?
Your answer should be compact. 1.04. What is the ratio of the Rating (1=low 6=high) in Upper middle income in 2008 to that in 2013?
Ensure brevity in your answer.  1.13. What is the ratio of the Rating (1=low 6=high) of Congo (Democratic) in 2008 to that in 2013?
Give a very brief answer. 1. What is the ratio of the Rating (1=low 6=high) of Lower middle income in 2008 to that in 2014?
Provide a succinct answer. 1.07. What is the ratio of the Rating (1=low 6=high) in Upper middle income in 2008 to that in 2014?
Your response must be concise. 1.22. What is the ratio of the Rating (1=low 6=high) in Benin in 2008 to that in 2014?
Your answer should be very brief. 1.14. What is the ratio of the Rating (1=low 6=high) of Upper middle income in 2009 to that in 2010?
Provide a succinct answer. 0.99. What is the ratio of the Rating (1=low 6=high) of Lower middle income in 2009 to that in 2011?
Give a very brief answer. 1.01. What is the ratio of the Rating (1=low 6=high) of Upper middle income in 2009 to that in 2011?
Give a very brief answer. 1.06. What is the ratio of the Rating (1=low 6=high) in Benin in 2009 to that in 2011?
Provide a succinct answer. 1.17. What is the ratio of the Rating (1=low 6=high) of Lower middle income in 2009 to that in 2012?
Your answer should be compact. 1.03. What is the ratio of the Rating (1=low 6=high) of Upper middle income in 2009 to that in 2012?
Your response must be concise. 1.13. What is the ratio of the Rating (1=low 6=high) of Benin in 2009 to that in 2012?
Provide a short and direct response. 1.17. What is the ratio of the Rating (1=low 6=high) of Lower middle income in 2009 to that in 2013?
Give a very brief answer. 1.04. What is the ratio of the Rating (1=low 6=high) in Upper middle income in 2009 to that in 2013?
Offer a very short reply. 1.15. What is the ratio of the Rating (1=low 6=high) in Benin in 2009 to that in 2013?
Give a very brief answer. 1. What is the ratio of the Rating (1=low 6=high) in Lower middle income in 2009 to that in 2014?
Provide a short and direct response. 1.07. What is the ratio of the Rating (1=low 6=high) in Upper middle income in 2009 to that in 2014?
Provide a short and direct response. 1.24. What is the ratio of the Rating (1=low 6=high) in Congo (Democratic) in 2009 to that in 2014?
Keep it short and to the point. 1. What is the ratio of the Rating (1=low 6=high) of Lower middle income in 2010 to that in 2011?
Your response must be concise. 1.01. What is the ratio of the Rating (1=low 6=high) in Upper middle income in 2010 to that in 2011?
Your response must be concise. 1.08. What is the ratio of the Rating (1=low 6=high) in Congo (Democratic) in 2010 to that in 2011?
Your answer should be very brief. 1. What is the ratio of the Rating (1=low 6=high) of Upper middle income in 2010 to that in 2012?
Offer a very short reply. 1.15. What is the ratio of the Rating (1=low 6=high) of Congo (Democratic) in 2010 to that in 2012?
Keep it short and to the point. 1. What is the ratio of the Rating (1=low 6=high) of Lower middle income in 2010 to that in 2013?
Make the answer very short. 1.04. What is the ratio of the Rating (1=low 6=high) of Upper middle income in 2010 to that in 2013?
Provide a succinct answer. 1.17. What is the ratio of the Rating (1=low 6=high) in Benin in 2010 to that in 2013?
Your answer should be compact. 0.86. What is the ratio of the Rating (1=low 6=high) in Lower middle income in 2010 to that in 2014?
Offer a terse response. 1.07. What is the ratio of the Rating (1=low 6=high) in Upper middle income in 2010 to that in 2014?
Make the answer very short. 1.26. What is the ratio of the Rating (1=low 6=high) in Benin in 2010 to that in 2014?
Offer a very short reply. 0.86. What is the ratio of the Rating (1=low 6=high) in Lower middle income in 2011 to that in 2012?
Your answer should be very brief. 1.01. What is the ratio of the Rating (1=low 6=high) in Upper middle income in 2011 to that in 2012?
Your answer should be very brief. 1.07. What is the ratio of the Rating (1=low 6=high) of Lower middle income in 2011 to that in 2013?
Your answer should be compact. 1.02. What is the ratio of the Rating (1=low 6=high) in Upper middle income in 2011 to that in 2013?
Offer a very short reply. 1.08. What is the ratio of the Rating (1=low 6=high) of Benin in 2011 to that in 2013?
Provide a succinct answer. 0.86. What is the ratio of the Rating (1=low 6=high) in Lower middle income in 2011 to that in 2014?
Provide a short and direct response. 1.05. What is the ratio of the Rating (1=low 6=high) in Upper middle income in 2011 to that in 2014?
Your answer should be very brief. 1.16. What is the ratio of the Rating (1=low 6=high) in Benin in 2011 to that in 2014?
Provide a short and direct response. 0.86. What is the ratio of the Rating (1=low 6=high) of Lower middle income in 2012 to that in 2013?
Provide a succinct answer. 1.01. What is the ratio of the Rating (1=low 6=high) in Upper middle income in 2012 to that in 2013?
Your answer should be very brief. 1.02. What is the ratio of the Rating (1=low 6=high) of Congo (Democratic) in 2012 to that in 2013?
Ensure brevity in your answer.  1. What is the ratio of the Rating (1=low 6=high) in Lower middle income in 2012 to that in 2014?
Your response must be concise. 1.04. What is the ratio of the Rating (1=low 6=high) in Congo (Democratic) in 2012 to that in 2014?
Ensure brevity in your answer.  1. What is the ratio of the Rating (1=low 6=high) of Lower middle income in 2013 to that in 2014?
Ensure brevity in your answer.  1.03. What is the ratio of the Rating (1=low 6=high) of Upper middle income in 2013 to that in 2014?
Your response must be concise. 1.07. What is the ratio of the Rating (1=low 6=high) in Congo (Democratic) in 2013 to that in 2014?
Provide a succinct answer. 1. What is the difference between the highest and the second highest Rating (1=low 6=high) of Lower middle income?
Provide a short and direct response. 0. What is the difference between the highest and the second highest Rating (1=low 6=high) of Upper middle income?
Offer a very short reply. 0.05. What is the difference between the highest and the second highest Rating (1=low 6=high) in Benin?
Your answer should be compact. 0. What is the difference between the highest and the second highest Rating (1=low 6=high) in Congo (Democratic)?
Provide a succinct answer. 0. What is the difference between the highest and the lowest Rating (1=low 6=high) of Lower middle income?
Provide a succinct answer. 0.24. What is the difference between the highest and the lowest Rating (1=low 6=high) in Upper middle income?
Provide a succinct answer. 0.68. What is the difference between the highest and the lowest Rating (1=low 6=high) of Benin?
Make the answer very short. 1. 